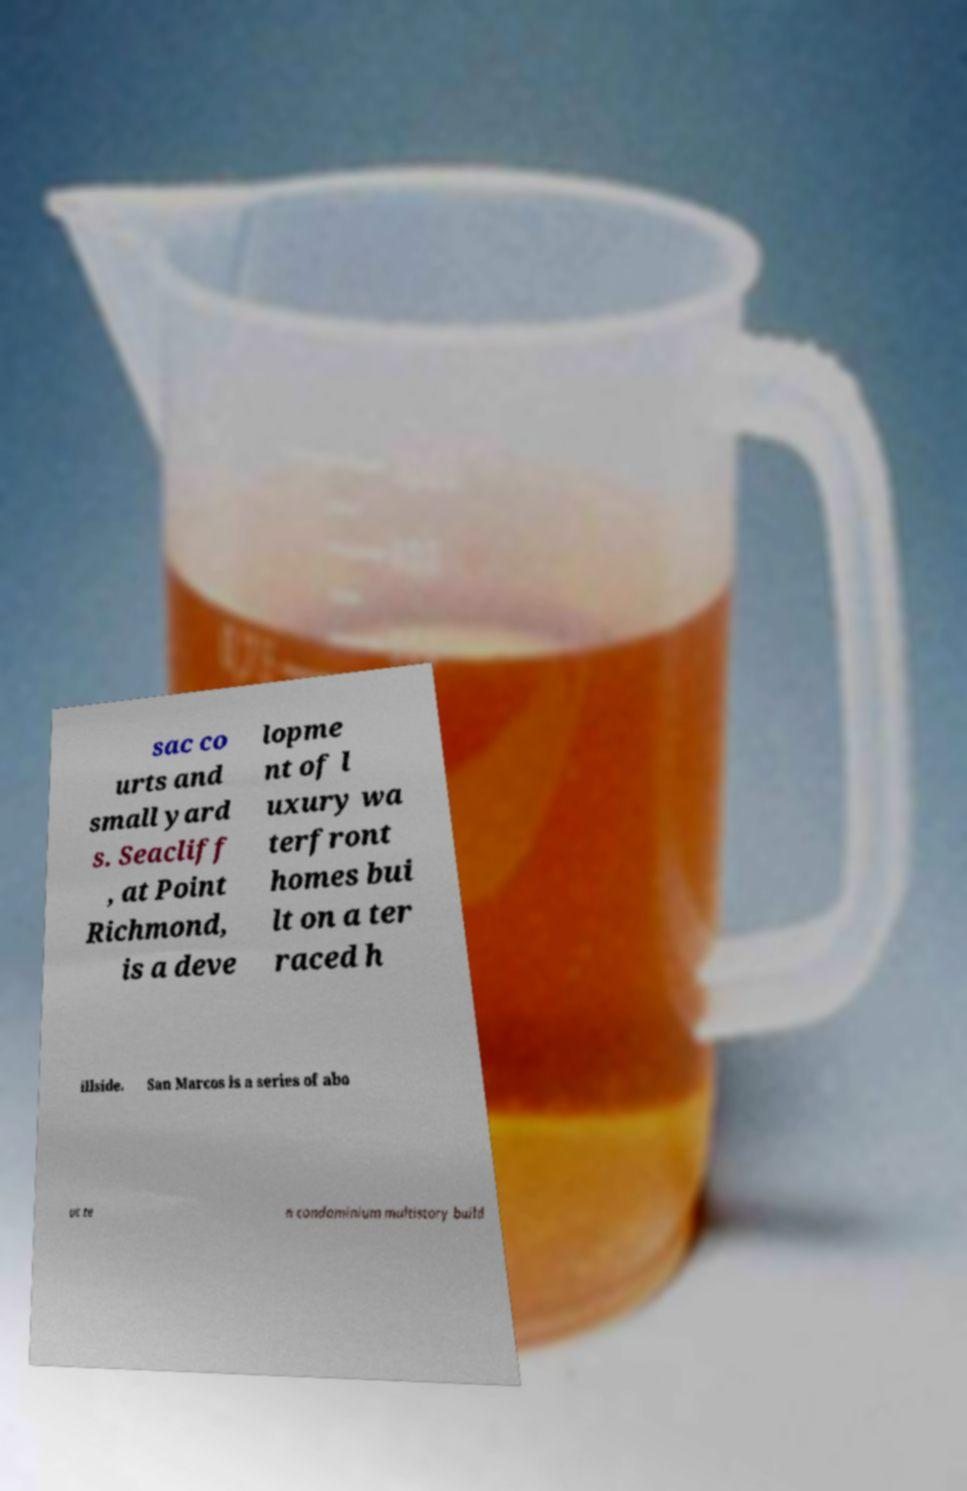I need the written content from this picture converted into text. Can you do that? sac co urts and small yard s. Seacliff , at Point Richmond, is a deve lopme nt of l uxury wa terfront homes bui lt on a ter raced h illside. San Marcos is a series of abo ut te n condominium multistory build 